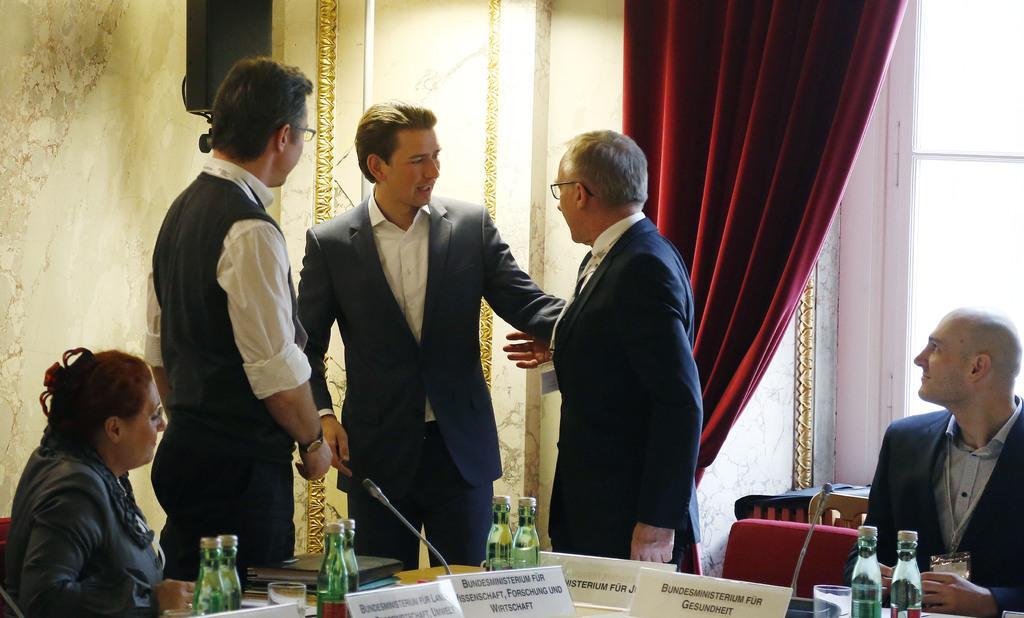In one or two sentences, can you explain what this image depicts? This 3 persons are standing. This 2 persons are sitting on a chair. On this table there are cards, bottles and books. This is a red curtain. 